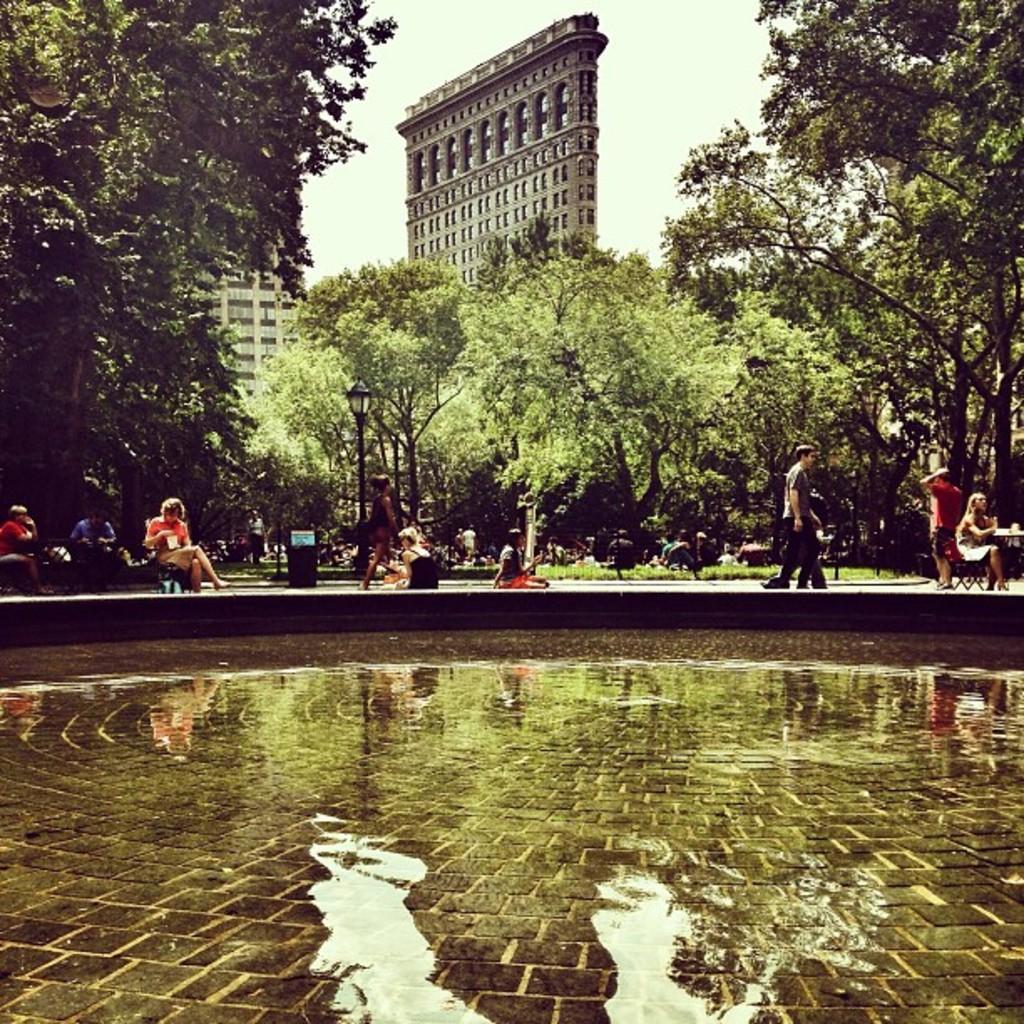Please provide a concise description of this image. In this image we can see a group of people beside a water body. On the backside we can see a group of trees, grass, a dustbin, a street lamp, some buildings with windows and the sky which looks cloudy. 